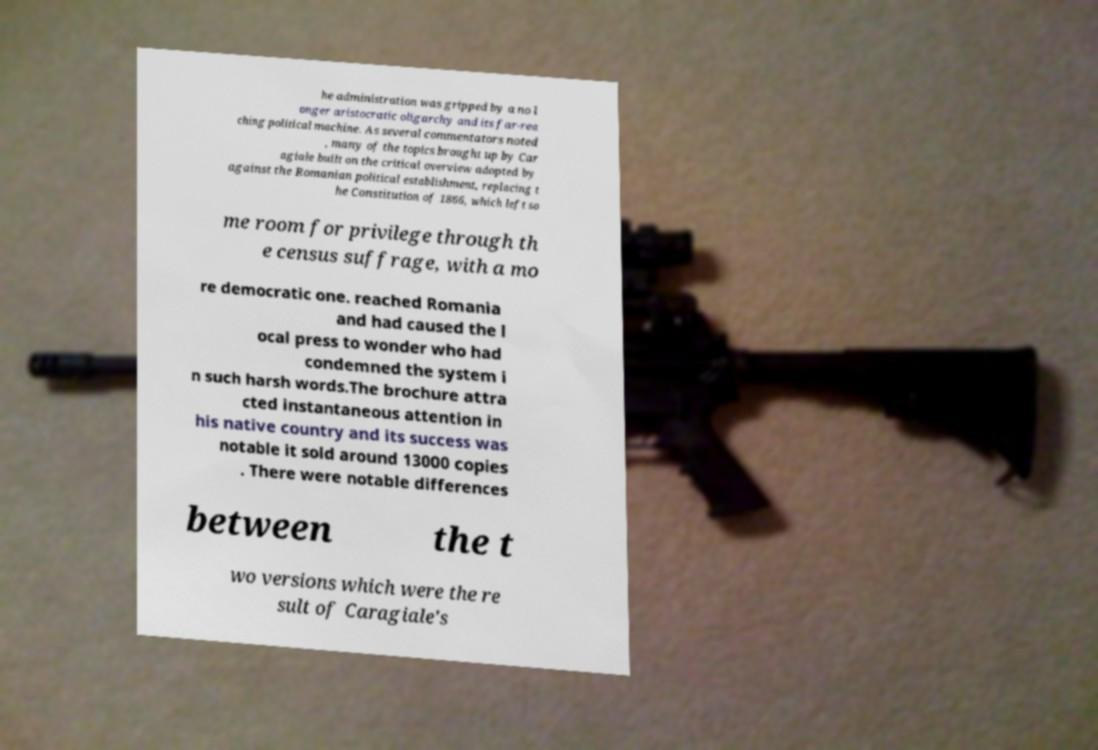Could you assist in decoding the text presented in this image and type it out clearly? he administration was gripped by a no l onger aristocratic oligarchy and its far-rea ching political machine. As several commentators noted , many of the topics brought up by Car agiale built on the critical overview adopted by against the Romanian political establishment, replacing t he Constitution of 1866, which left so me room for privilege through th e census suffrage, with a mo re democratic one. reached Romania and had caused the l ocal press to wonder who had condemned the system i n such harsh words.The brochure attra cted instantaneous attention in his native country and its success was notable it sold around 13000 copies . There were notable differences between the t wo versions which were the re sult of Caragiale's 